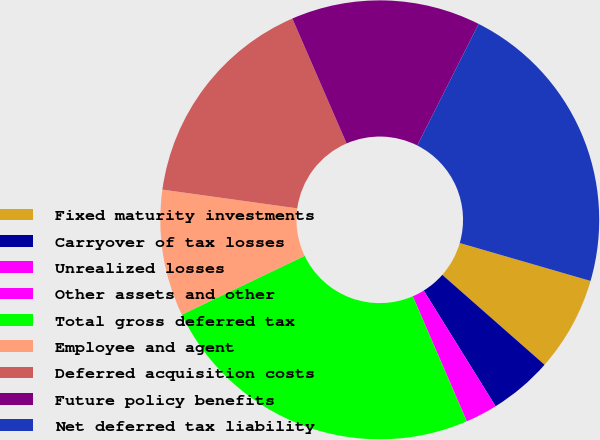Convert chart. <chart><loc_0><loc_0><loc_500><loc_500><pie_chart><fcel>Fixed maturity investments<fcel>Carryover of tax losses<fcel>Unrealized losses<fcel>Other assets and other<fcel>Total gross deferred tax<fcel>Employee and agent<fcel>Deferred acquisition costs<fcel>Future policy benefits<fcel>Net deferred tax liability<nl><fcel>6.99%<fcel>4.67%<fcel>2.35%<fcel>0.02%<fcel>24.37%<fcel>9.31%<fcel>16.28%<fcel>13.96%<fcel>22.05%<nl></chart> 